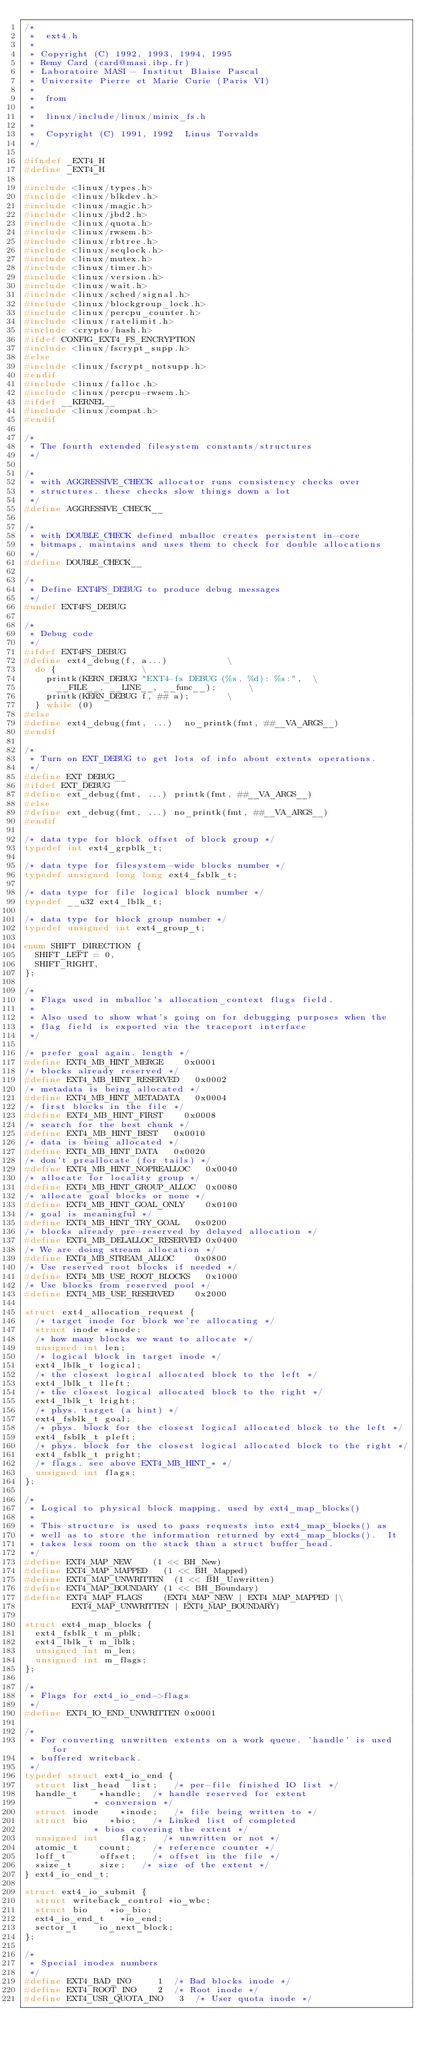<code> <loc_0><loc_0><loc_500><loc_500><_C_>/*
 *  ext4.h
 *
 * Copyright (C) 1992, 1993, 1994, 1995
 * Remy Card (card@masi.ibp.fr)
 * Laboratoire MASI - Institut Blaise Pascal
 * Universite Pierre et Marie Curie (Paris VI)
 *
 *  from
 *
 *  linux/include/linux/minix_fs.h
 *
 *  Copyright (C) 1991, 1992  Linus Torvalds
 */

#ifndef _EXT4_H
#define _EXT4_H

#include <linux/types.h>
#include <linux/blkdev.h>
#include <linux/magic.h>
#include <linux/jbd2.h>
#include <linux/quota.h>
#include <linux/rwsem.h>
#include <linux/rbtree.h>
#include <linux/seqlock.h>
#include <linux/mutex.h>
#include <linux/timer.h>
#include <linux/version.h>
#include <linux/wait.h>
#include <linux/sched/signal.h>
#include <linux/blockgroup_lock.h>
#include <linux/percpu_counter.h>
#include <linux/ratelimit.h>
#include <crypto/hash.h>
#ifdef CONFIG_EXT4_FS_ENCRYPTION
#include <linux/fscrypt_supp.h>
#else
#include <linux/fscrypt_notsupp.h>
#endif
#include <linux/falloc.h>
#include <linux/percpu-rwsem.h>
#ifdef __KERNEL__
#include <linux/compat.h>
#endif

/*
 * The fourth extended filesystem constants/structures
 */

/*
 * with AGGRESSIVE_CHECK allocator runs consistency checks over
 * structures. these checks slow things down a lot
 */
#define AGGRESSIVE_CHECK__

/*
 * with DOUBLE_CHECK defined mballoc creates persistent in-core
 * bitmaps, maintains and uses them to check for double allocations
 */
#define DOUBLE_CHECK__

/*
 * Define EXT4FS_DEBUG to produce debug messages
 */
#undef EXT4FS_DEBUG

/*
 * Debug code
 */
#ifdef EXT4FS_DEBUG
#define ext4_debug(f, a...)						\
	do {								\
		printk(KERN_DEBUG "EXT4-fs DEBUG (%s, %d): %s:",	\
			__FILE__, __LINE__, __func__);			\
		printk(KERN_DEBUG f, ## a);				\
	} while (0)
#else
#define ext4_debug(fmt, ...)	no_printk(fmt, ##__VA_ARGS__)
#endif

/*
 * Turn on EXT_DEBUG to get lots of info about extents operations.
 */
#define EXT_DEBUG__
#ifdef EXT_DEBUG
#define ext_debug(fmt, ...)	printk(fmt, ##__VA_ARGS__)
#else
#define ext_debug(fmt, ...)	no_printk(fmt, ##__VA_ARGS__)
#endif

/* data type for block offset of block group */
typedef int ext4_grpblk_t;

/* data type for filesystem-wide blocks number */
typedef unsigned long long ext4_fsblk_t;

/* data type for file logical block number */
typedef __u32 ext4_lblk_t;

/* data type for block group number */
typedef unsigned int ext4_group_t;

enum SHIFT_DIRECTION {
	SHIFT_LEFT = 0,
	SHIFT_RIGHT,
};

/*
 * Flags used in mballoc's allocation_context flags field.
 *
 * Also used to show what's going on for debugging purposes when the
 * flag field is exported via the traceport interface
 */

/* prefer goal again. length */
#define EXT4_MB_HINT_MERGE		0x0001
/* blocks already reserved */
#define EXT4_MB_HINT_RESERVED		0x0002
/* metadata is being allocated */
#define EXT4_MB_HINT_METADATA		0x0004
/* first blocks in the file */
#define EXT4_MB_HINT_FIRST		0x0008
/* search for the best chunk */
#define EXT4_MB_HINT_BEST		0x0010
/* data is being allocated */
#define EXT4_MB_HINT_DATA		0x0020
/* don't preallocate (for tails) */
#define EXT4_MB_HINT_NOPREALLOC		0x0040
/* allocate for locality group */
#define EXT4_MB_HINT_GROUP_ALLOC	0x0080
/* allocate goal blocks or none */
#define EXT4_MB_HINT_GOAL_ONLY		0x0100
/* goal is meaningful */
#define EXT4_MB_HINT_TRY_GOAL		0x0200
/* blocks already pre-reserved by delayed allocation */
#define EXT4_MB_DELALLOC_RESERVED	0x0400
/* We are doing stream allocation */
#define EXT4_MB_STREAM_ALLOC		0x0800
/* Use reserved root blocks if needed */
#define EXT4_MB_USE_ROOT_BLOCKS		0x1000
/* Use blocks from reserved pool */
#define EXT4_MB_USE_RESERVED		0x2000

struct ext4_allocation_request {
	/* target inode for block we're allocating */
	struct inode *inode;
	/* how many blocks we want to allocate */
	unsigned int len;
	/* logical block in target inode */
	ext4_lblk_t logical;
	/* the closest logical allocated block to the left */
	ext4_lblk_t lleft;
	/* the closest logical allocated block to the right */
	ext4_lblk_t lright;
	/* phys. target (a hint) */
	ext4_fsblk_t goal;
	/* phys. block for the closest logical allocated block to the left */
	ext4_fsblk_t pleft;
	/* phys. block for the closest logical allocated block to the right */
	ext4_fsblk_t pright;
	/* flags. see above EXT4_MB_HINT_* */
	unsigned int flags;
};

/*
 * Logical to physical block mapping, used by ext4_map_blocks()
 *
 * This structure is used to pass requests into ext4_map_blocks() as
 * well as to store the information returned by ext4_map_blocks().  It
 * takes less room on the stack than a struct buffer_head.
 */
#define EXT4_MAP_NEW		(1 << BH_New)
#define EXT4_MAP_MAPPED		(1 << BH_Mapped)
#define EXT4_MAP_UNWRITTEN	(1 << BH_Unwritten)
#define EXT4_MAP_BOUNDARY	(1 << BH_Boundary)
#define EXT4_MAP_FLAGS		(EXT4_MAP_NEW | EXT4_MAP_MAPPED |\
				 EXT4_MAP_UNWRITTEN | EXT4_MAP_BOUNDARY)

struct ext4_map_blocks {
	ext4_fsblk_t m_pblk;
	ext4_lblk_t m_lblk;
	unsigned int m_len;
	unsigned int m_flags;
};

/*
 * Flags for ext4_io_end->flags
 */
#define	EXT4_IO_END_UNWRITTEN	0x0001

/*
 * For converting unwritten extents on a work queue. 'handle' is used for
 * buffered writeback.
 */
typedef struct ext4_io_end {
	struct list_head	list;		/* per-file finished IO list */
	handle_t		*handle;	/* handle reserved for extent
						 * conversion */
	struct inode		*inode;		/* file being written to */
	struct bio		*bio;		/* Linked list of completed
						 * bios covering the extent */
	unsigned int		flag;		/* unwritten or not */
	atomic_t		count;		/* reference counter */
	loff_t			offset;		/* offset in the file */
	ssize_t			size;		/* size of the extent */
} ext4_io_end_t;

struct ext4_io_submit {
	struct writeback_control *io_wbc;
	struct bio		*io_bio;
	ext4_io_end_t		*io_end;
	sector_t		io_next_block;
};

/*
 * Special inodes numbers
 */
#define	EXT4_BAD_INO		 1	/* Bad blocks inode */
#define EXT4_ROOT_INO		 2	/* Root inode */
#define EXT4_USR_QUOTA_INO	 3	/* User quota inode */</code> 